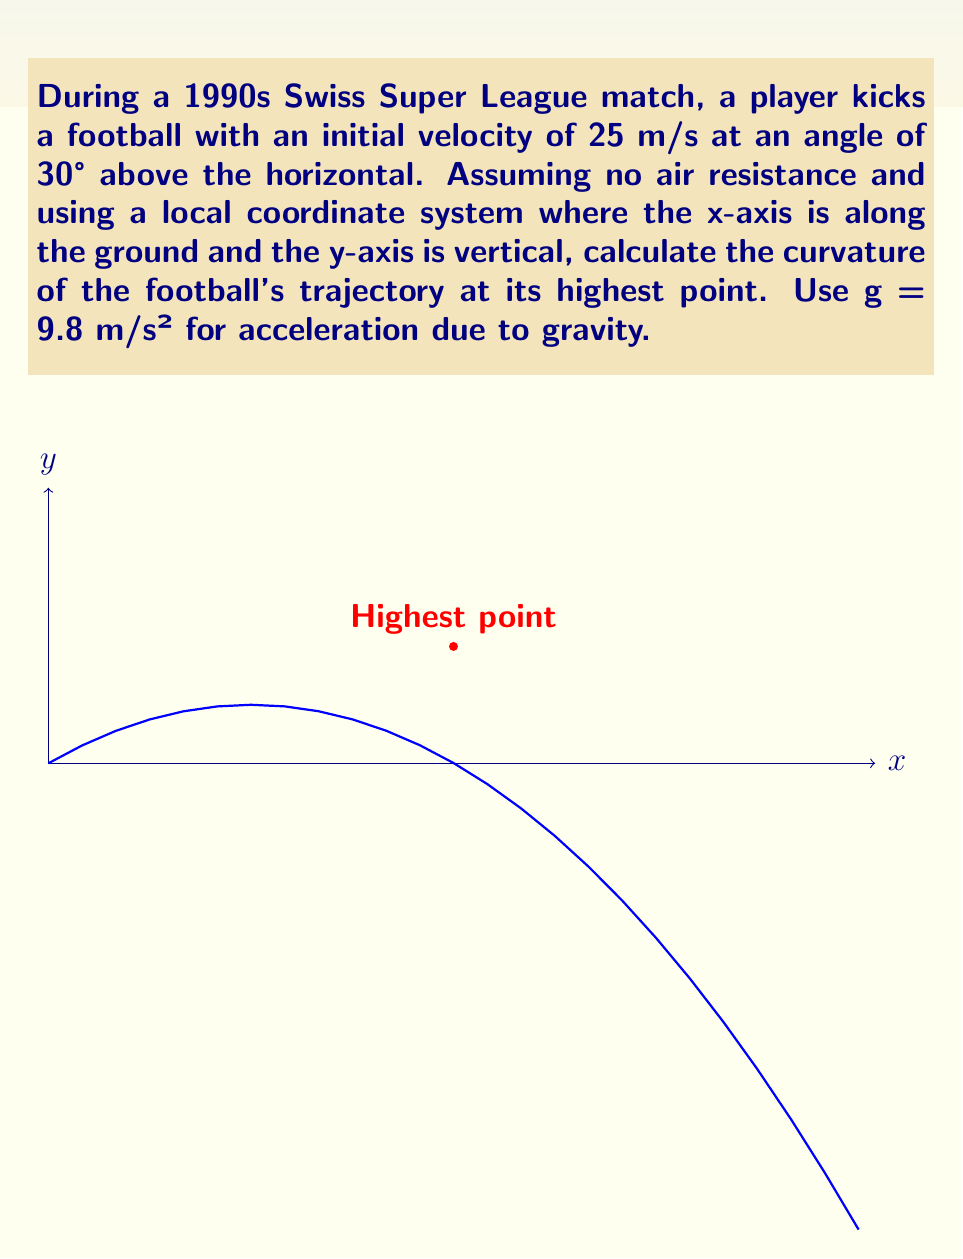Solve this math problem. Let's approach this step-by-step:

1) First, we need to find the parametric equations of motion:
   $$x(t) = v_0 \cos(\theta) t$$
   $$y(t) = v_0 \sin(\theta) t - \frac{1}{2}gt^2$$

   Where $v_0 = 25$ m/s, $\theta = 30°$, and $g = 9.8$ m/s².

2) Substituting the values:
   $$x(t) = 25 \cos(30°) t = 21.65t$$
   $$y(t) = 25 \sin(30°) t - 4.9t^2 = 12.5t - 4.9t^2$$

3) The curvature $\kappa$ of a parametric curve is given by:
   $$\kappa = \frac{|\dot{x}\ddot{y} - \dot{y}\ddot{x}|}{(\dot{x}^2 + \dot{y}^2)^{3/2}}$$

4) We need to calculate $\dot{x}$, $\ddot{x}$, $\dot{y}$, and $\ddot{y}$:
   $$\dot{x} = 21.65, \ddot{x} = 0$$
   $$\dot{y} = 12.5 - 9.8t, \ddot{y} = -9.8$$

5) At the highest point, $\dot{y} = 0$. So:
   $$12.5 - 9.8t = 0$$
   $$t = \frac{12.5}{9.8} = 1.276\text{ s}$$

6) Now we can calculate the curvature at the highest point:
   $$\kappa = \frac{|21.65(-9.8) - 0(0)|}{(21.65^2 + 0^2)^{3/2}}$$

7) Simplifying:
   $$\kappa = \frac{212.17}{10141.45} = 0.0209\text{ m}^{-1}$$
Answer: $0.0209\text{ m}^{-1}$ 